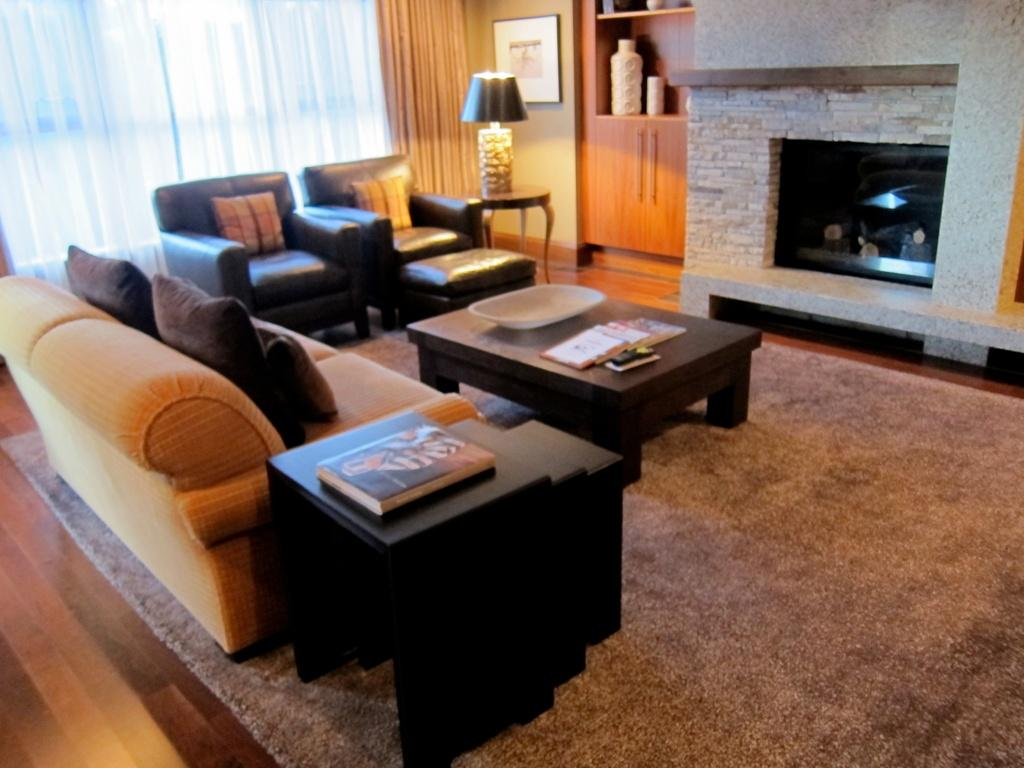What type of furniture is present in the image? There are sofas in the image. What can be seen on the sofas in the image? There are pillows in the image. What type of window treatment is visible in the image? There is a curtain in the image. What type of lighting is present in the image? There is a lamp in the image. What type of carriage can be seen in the image? There is no carriage present in the image. How does the current affect the pillows in the image? There is no mention of a current in the image, and the pillows are not affected by any current. 